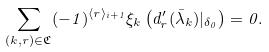Convert formula to latex. <formula><loc_0><loc_0><loc_500><loc_500>\sum _ { ( k , r ) \in \mathfrak C } ( - 1 ) ^ { \langle r \rangle _ { i + 1 } } \xi _ { k } \left ( d ^ { \prime } _ { r } ( \bar { \lambda } _ { k } ) | _ { \delta _ { 0 } } \right ) = 0 .</formula> 